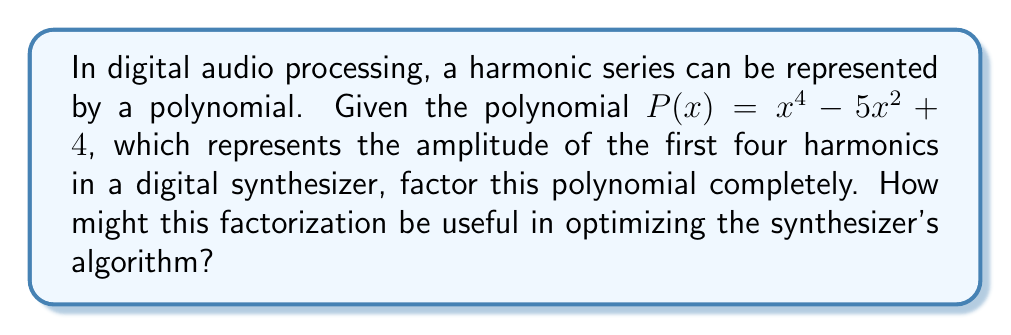Give your solution to this math problem. Let's approach this step-by-step:

1) First, we recognize that this is a quadratic equation in $x^2$. Let's substitute $u = x^2$:

   $P(u) = u^2 - 5u + 4$

2) Now we can factor this quadratic:
   
   $u^2 - 5u + 4 = (u - 1)(u - 4)$

3) Substituting back $x^2$ for $u$:

   $x^4 - 5x^2 + 4 = (x^2 - 1)(x^2 - 4)$

4) We can factor these further:

   $(x^2 - 1) = (x + 1)(x - 1)$
   $(x^2 - 4) = (x + 2)(x - 2)$

5) Therefore, the complete factorization is:

   $P(x) = (x + 1)(x - 1)(x + 2)(x - 2)$

This factorization could be useful in optimizing the synthesizer's algorithm because:

1) It breaks down the complex polynomial into simpler linear factors.
2) Each factor $(x ± n)$ represents a simple operation that can be efficiently computed.
3) The zeroes of the polynomial (±1 and ±2) represent frequencies where the amplitude goes to zero, which could be used to fine-tune the harmonic content of the synthesized sound.
4) Understanding the structure of the polynomial allows for more efficient computation and potentially more precise control over the harmonic series in the synthesized sound.
Answer: $(x + 1)(x - 1)(x + 2)(x - 2)$ 